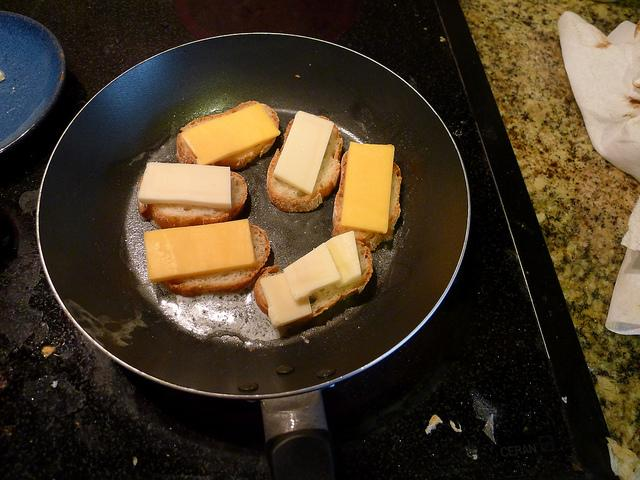What will happen to the yellow and white slices?

Choices:
A) will evaporate
B) will burn
C) get crispy
D) will melt will melt 